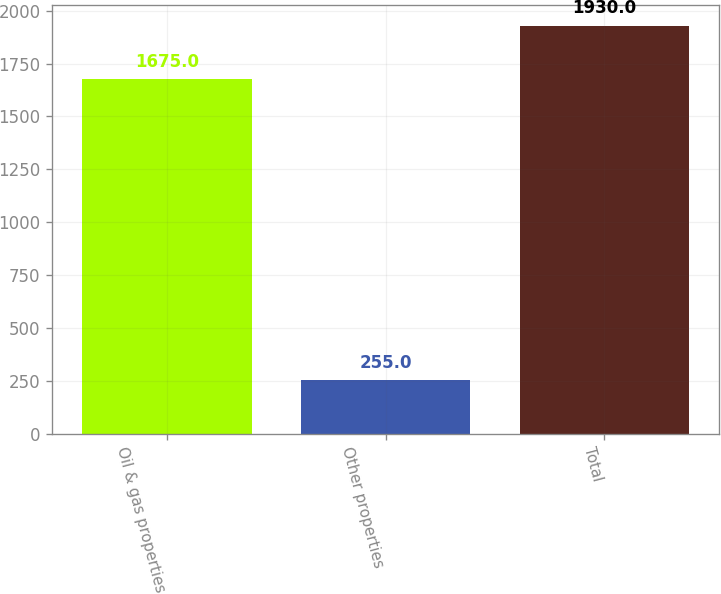Convert chart. <chart><loc_0><loc_0><loc_500><loc_500><bar_chart><fcel>Oil & gas properties<fcel>Other properties<fcel>Total<nl><fcel>1675<fcel>255<fcel>1930<nl></chart> 